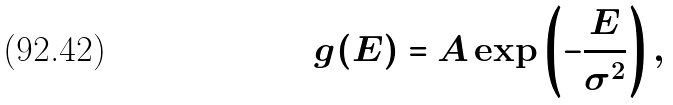<formula> <loc_0><loc_0><loc_500><loc_500>g ( E ) = A \exp \left ( - \frac { E } { \sigma ^ { 2 } } \right ) ,</formula> 